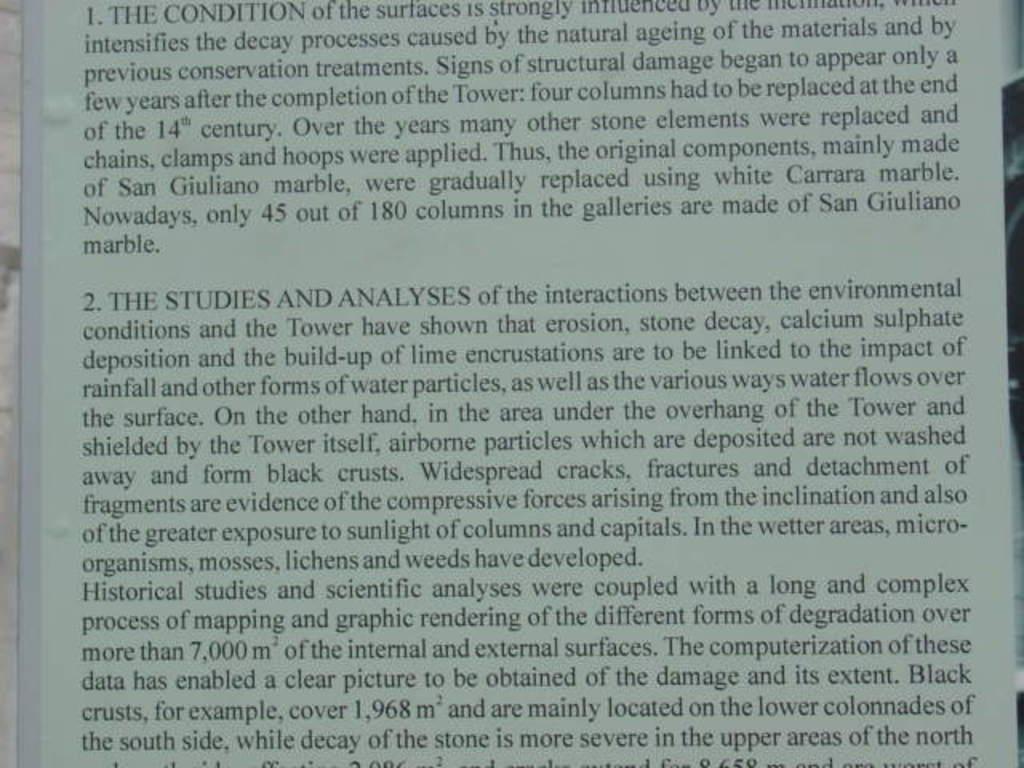Section 2 of this report is titled what?
Your response must be concise. The studies and analyses. Is this a book?
Ensure brevity in your answer.  Unanswerable. 